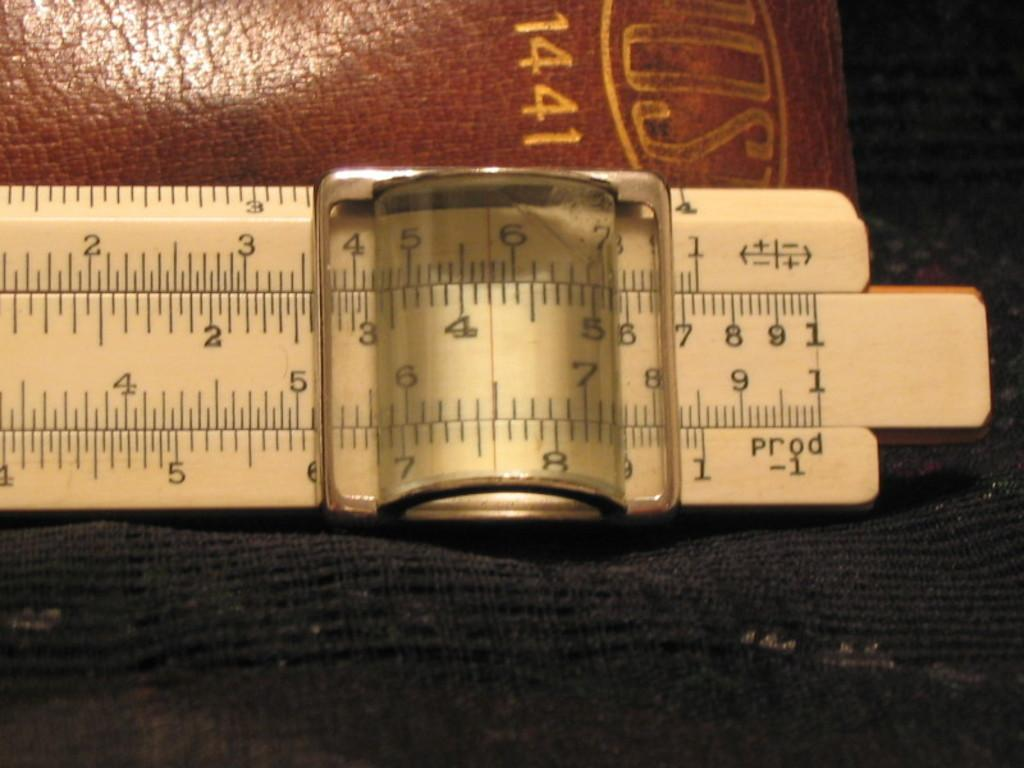<image>
Render a clear and concise summary of the photo. A ruler has it's slider set to just under 7 inches. 